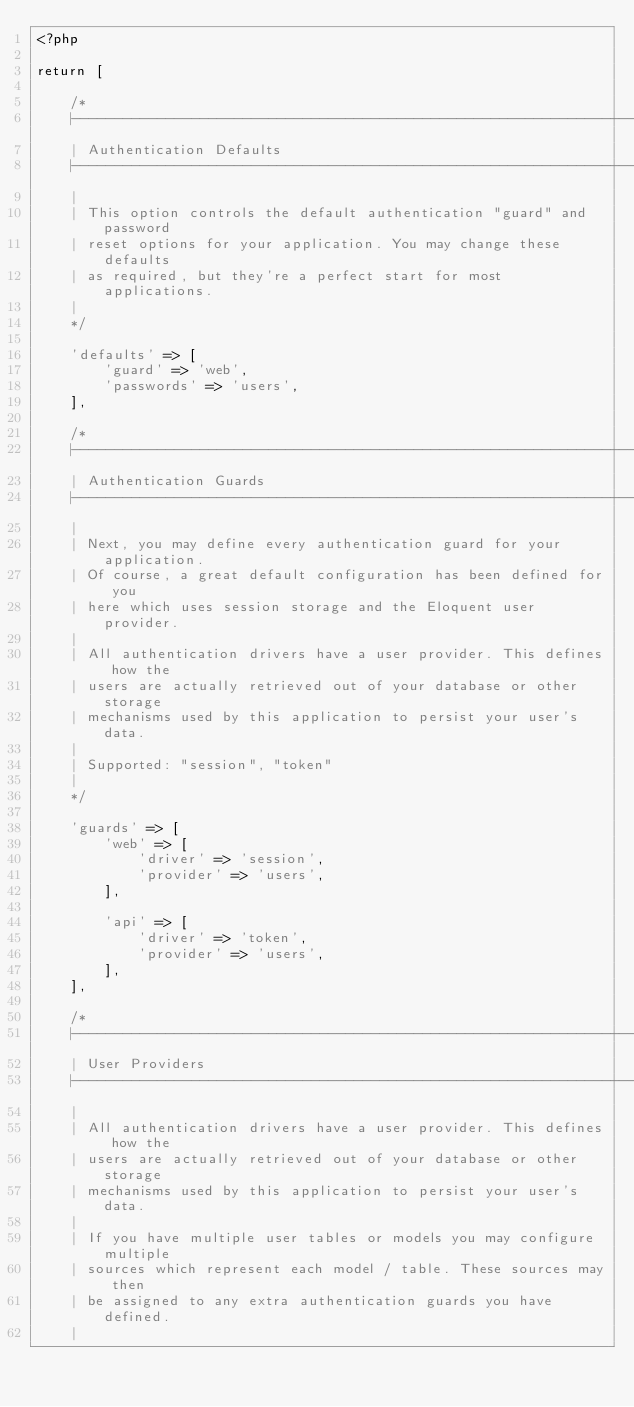Convert code to text. <code><loc_0><loc_0><loc_500><loc_500><_PHP_><?php

return [

    /*
    |--------------------------------------------------------------------------
    | Authentication Defaults
    |--------------------------------------------------------------------------
    |
    | This option controls the default authentication "guard" and password
    | reset options for your application. You may change these defaults
    | as required, but they're a perfect start for most applications.
    |
    */

    'defaults' => [
        'guard' => 'web',
        'passwords' => 'users',
    ],

    /*
    |--------------------------------------------------------------------------
    | Authentication Guards
    |--------------------------------------------------------------------------
    |
    | Next, you may define every authentication guard for your application.
    | Of course, a great default configuration has been defined for you
    | here which uses session storage and the Eloquent user provider.
    |
    | All authentication drivers have a user provider. This defines how the
    | users are actually retrieved out of your database or other storage
    | mechanisms used by this application to persist your user's data.
    |
    | Supported: "session", "token"
    |
    */

    'guards' => [
        'web' => [
            'driver' => 'session',
            'provider' => 'users',
        ],

        'api' => [
            'driver' => 'token',
            'provider' => 'users',
        ],
    ],

    /*
    |--------------------------------------------------------------------------
    | User Providers
    |--------------------------------------------------------------------------
    |
    | All authentication drivers have a user provider. This defines how the
    | users are actually retrieved out of your database or other storage
    | mechanisms used by this application to persist your user's data.
    |
    | If you have multiple user tables or models you may configure multiple
    | sources which represent each model / table. These sources may then
    | be assigned to any extra authentication guards you have defined.
    |</code> 